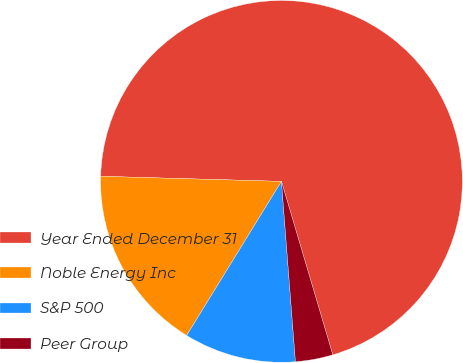Convert chart to OTSL. <chart><loc_0><loc_0><loc_500><loc_500><pie_chart><fcel>Year Ended December 31<fcel>Noble Energy Inc<fcel>S&P 500<fcel>Peer Group<nl><fcel>69.97%<fcel>16.67%<fcel>10.01%<fcel>3.35%<nl></chart> 